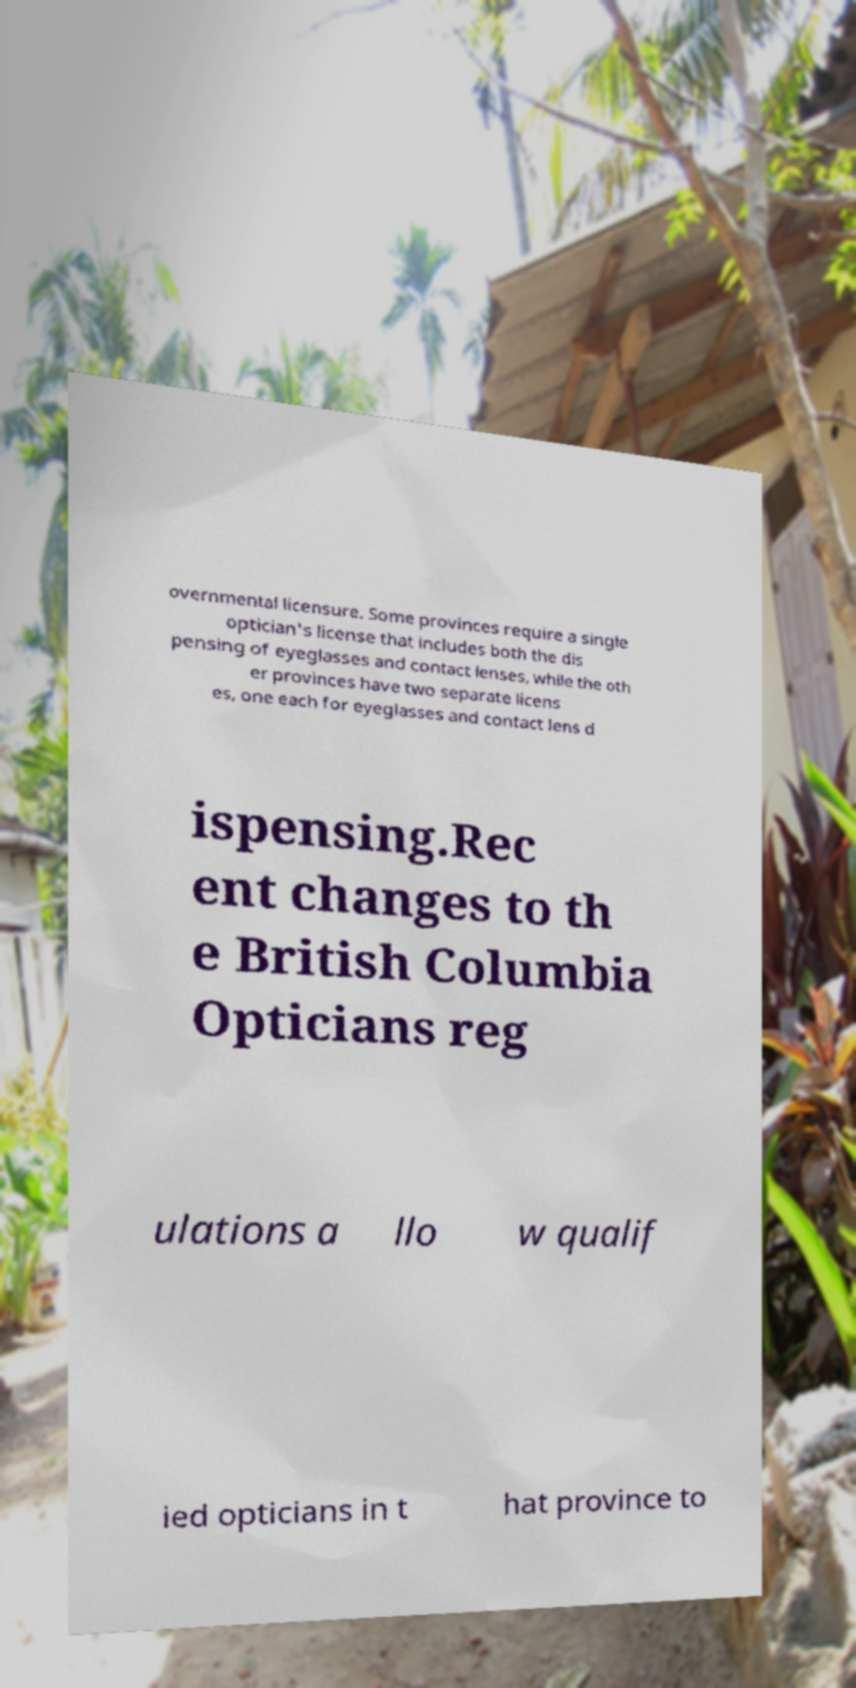For documentation purposes, I need the text within this image transcribed. Could you provide that? overnmental licensure. Some provinces require a single optician's license that includes both the dis pensing of eyeglasses and contact lenses, while the oth er provinces have two separate licens es, one each for eyeglasses and contact lens d ispensing.Rec ent changes to th e British Columbia Opticians reg ulations a llo w qualif ied opticians in t hat province to 